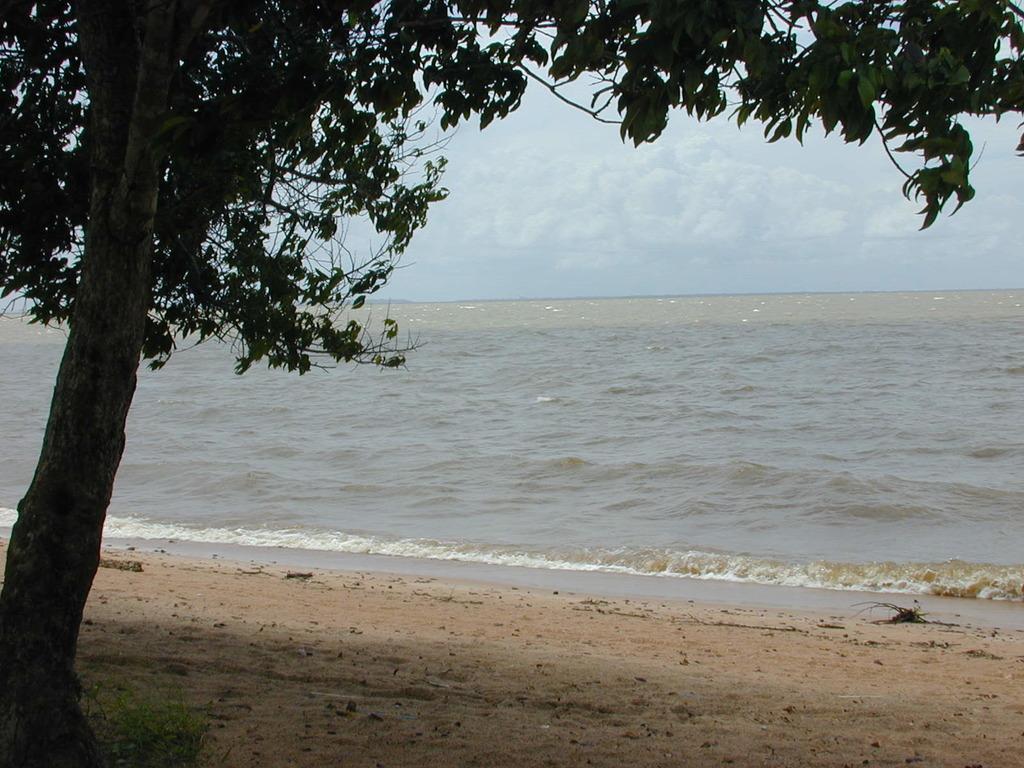Could you give a brief overview of what you see in this image? This looks like a seashore. I think these are the water flowing. This is a tree with the branches and leaves. 